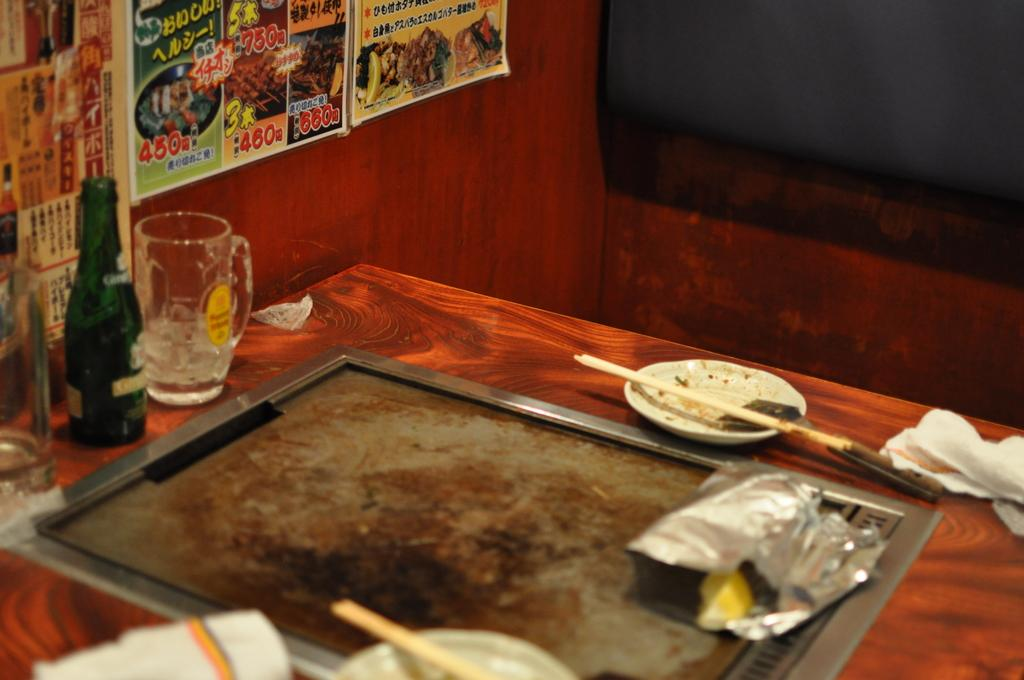What objects are on the table in the image? There is a bottle, a glass, a plate, a stick, and a tissue on the table in the image. What can be seen in the background of the image? There are posters and a wall in the background of the image. What type of tooth is visible on the table in the image? There is no tooth present on the table in the image. How does the image depict the act of saying good-bye? The image does not depict the act of saying good-bye; it only shows objects on a table and posters in the background. 